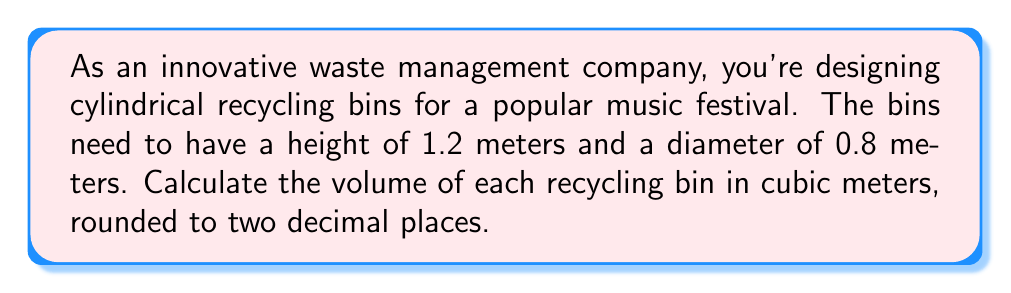Help me with this question. To calculate the volume of a cylindrical recycling bin, we need to use the formula for the volume of a cylinder:

$$V = \pi r^2 h$$

Where:
$V$ = volume of the cylinder
$\pi$ = pi (approximately 3.14159)
$r$ = radius of the base of the cylinder
$h$ = height of the cylinder

Given:
- Height (h) = 1.2 meters
- Diameter = 0.8 meters

Step 1: Calculate the radius
The radius is half the diameter:
$$r = \frac{0.8}{2} = 0.4 \text{ meters}$$

Step 2: Apply the volume formula
$$V = \pi (0.4 \text{ m})^2 (1.2 \text{ m})$$

Step 3: Calculate the result
$$V = \pi (0.16 \text{ m}^2) (1.2 \text{ m})$$
$$V = 0.6032\pi \text{ m}^3$$
$$V \approx 1.8945 \text{ m}^3$$

Step 4: Round to two decimal places
$$V \approx 1.89 \text{ m}^3$$

Therefore, the volume of each recycling bin is approximately 1.89 cubic meters.
Answer: $1.89 \text{ m}^3$ 